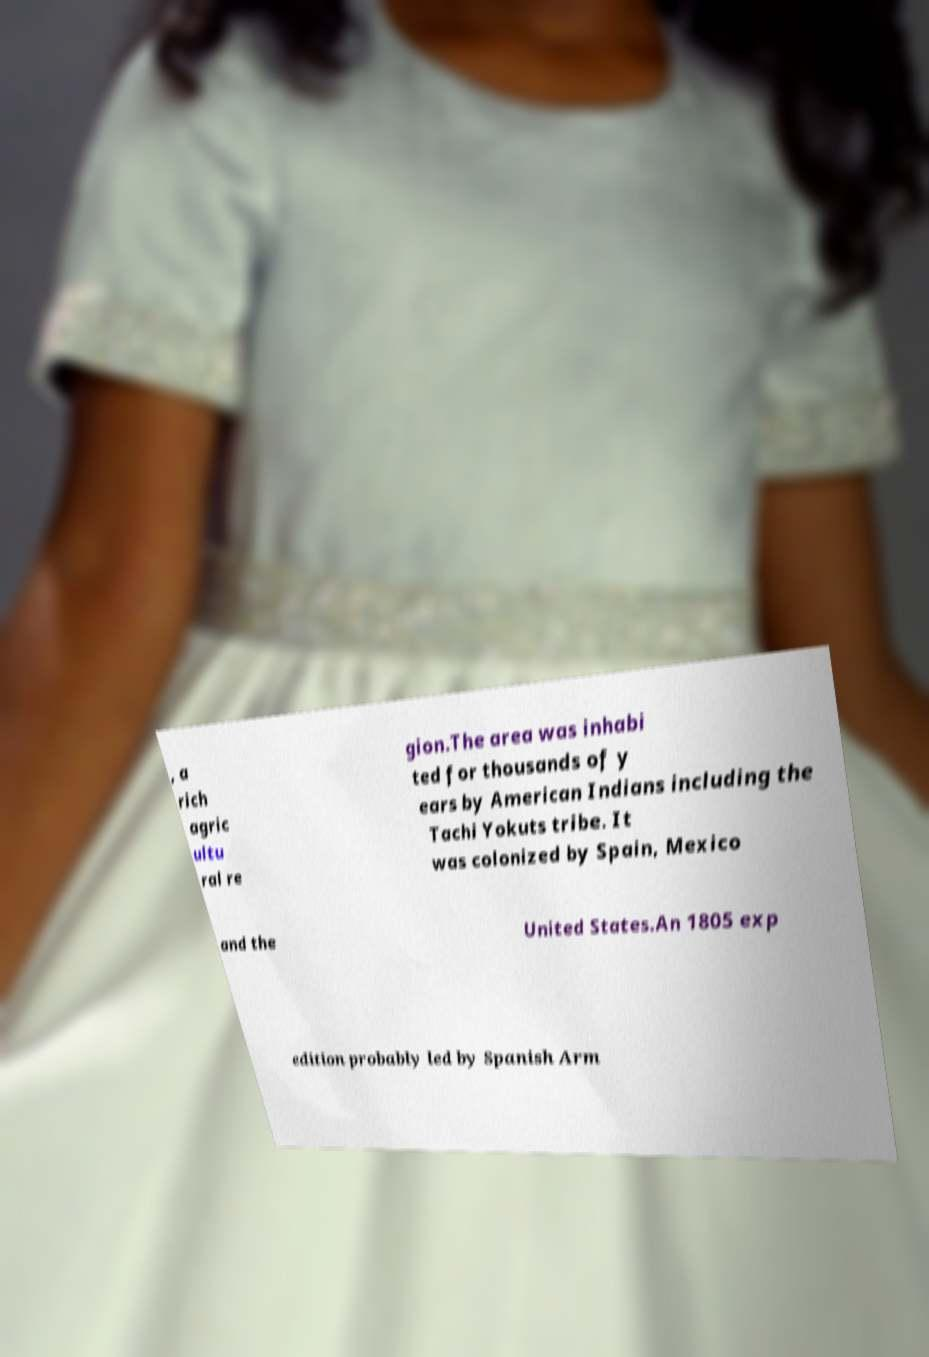What messages or text are displayed in this image? I need them in a readable, typed format. , a rich agric ultu ral re gion.The area was inhabi ted for thousands of y ears by American Indians including the Tachi Yokuts tribe. It was colonized by Spain, Mexico and the United States.An 1805 exp edition probably led by Spanish Arm 